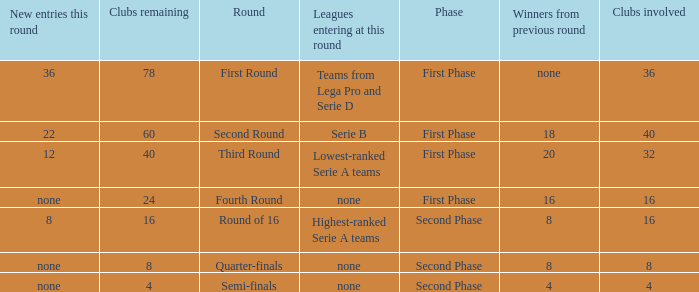During the first phase portion of phase and having 16 clubs involved; what would you find for the winners from previous round? 16.0. 